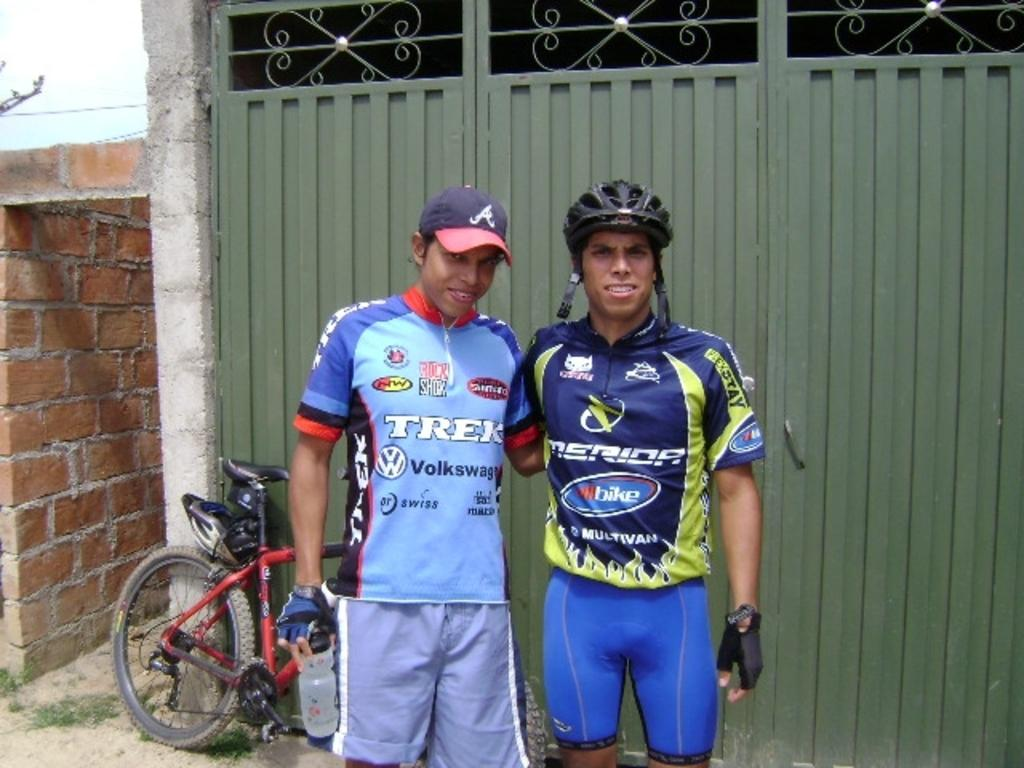How many people are in the foreground of the image? There are two men standing in the foreground. What can be seen in the background of the image? There is a gate and a brick wall in the image. What mode of transportation is present in the image? There is a bicycle in the image. What part of the natural environment is visible in the image? The sky is visible in the top left corner of the image. What type of stem can be seen growing from the bicycle in the image? There is no stem growing from the bicycle in the image. What sound can be heard coming from the sky in the image? There is no sound mentioned in the image, and the sky is not described as producing any sound. 